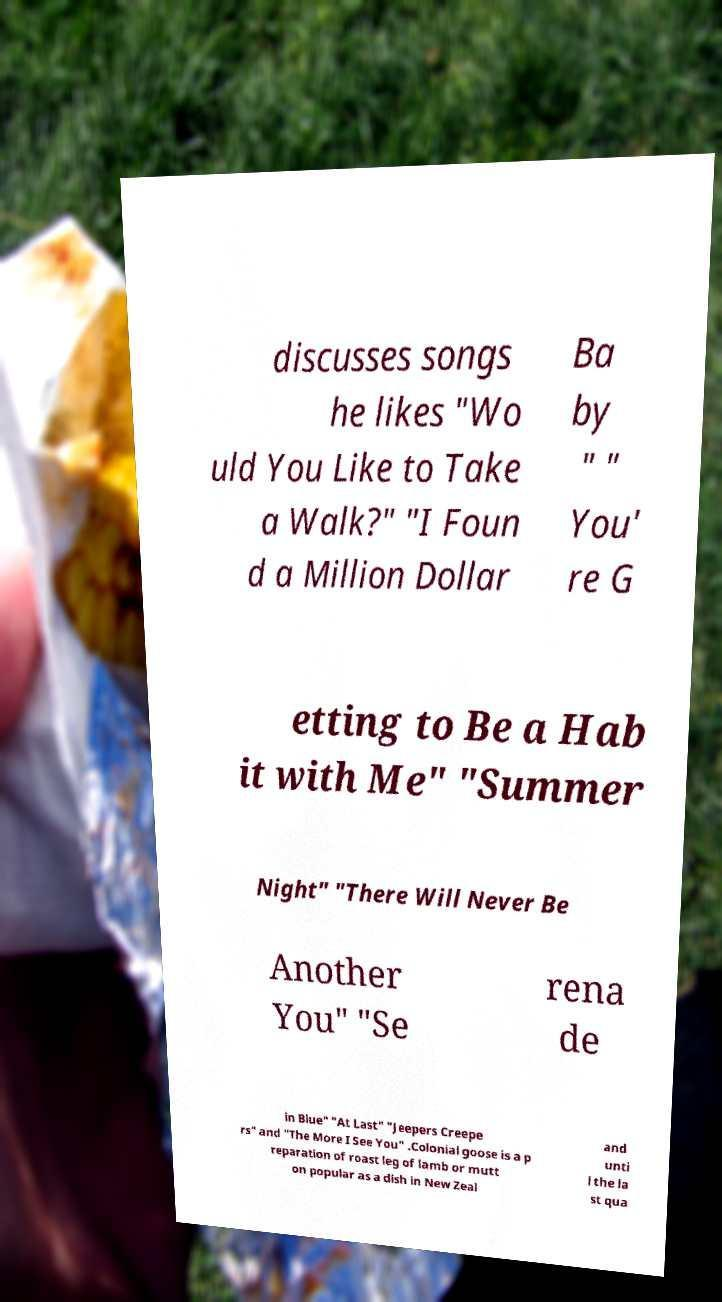Could you extract and type out the text from this image? discusses songs he likes "Wo uld You Like to Take a Walk?" "I Foun d a Million Dollar Ba by " " You' re G etting to Be a Hab it with Me" "Summer Night" "There Will Never Be Another You" "Se rena de in Blue" "At Last" "Jeepers Creepe rs" and "The More I See You" .Colonial goose is a p reparation of roast leg of lamb or mutt on popular as a dish in New Zeal and unti l the la st qua 